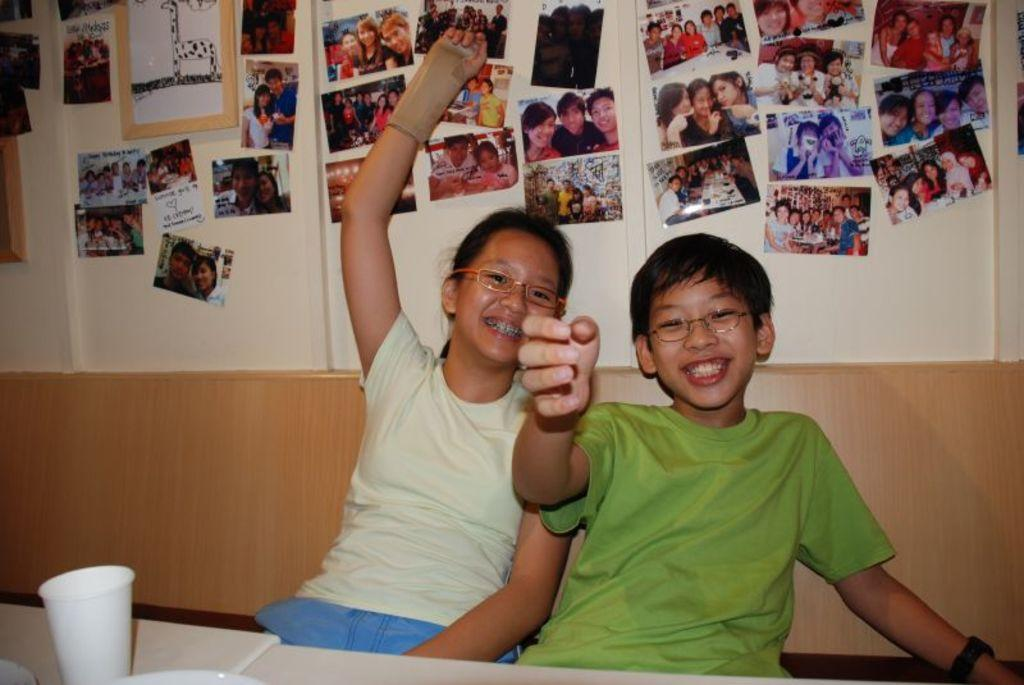How many kids are in the image? There are two kids in the image. What are the kids doing in the image? The kids are sitting and smiling. What can be seen on the wall behind the kids? There are many photographs on the wall behind the kids. What type of chairs are the kids sitting on in the image? There is no specific mention of chairs in the image, so we cannot determine the type of chairs the kids are sitting on. 